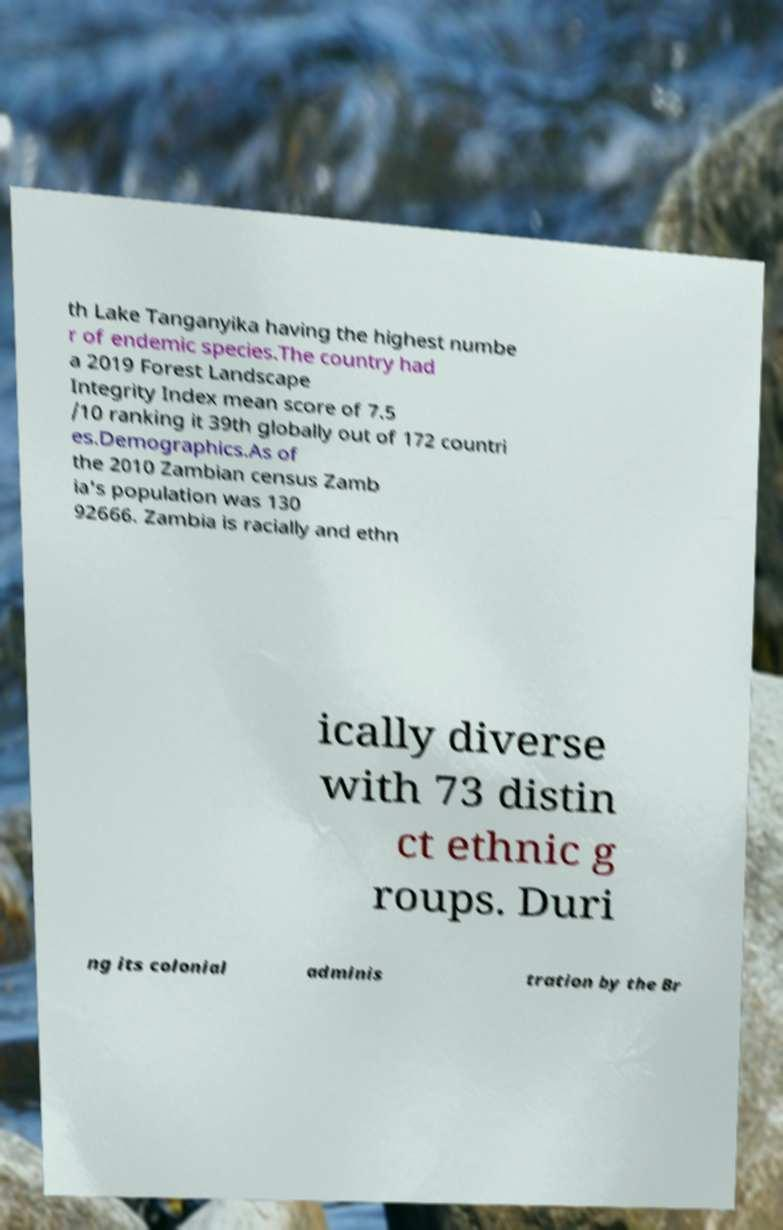Can you read and provide the text displayed in the image?This photo seems to have some interesting text. Can you extract and type it out for me? th Lake Tanganyika having the highest numbe r of endemic species.The country had a 2019 Forest Landscape Integrity Index mean score of 7.5 /10 ranking it 39th globally out of 172 countri es.Demographics.As of the 2010 Zambian census Zamb ia's population was 130 92666. Zambia is racially and ethn ically diverse with 73 distin ct ethnic g roups. Duri ng its colonial adminis tration by the Br 